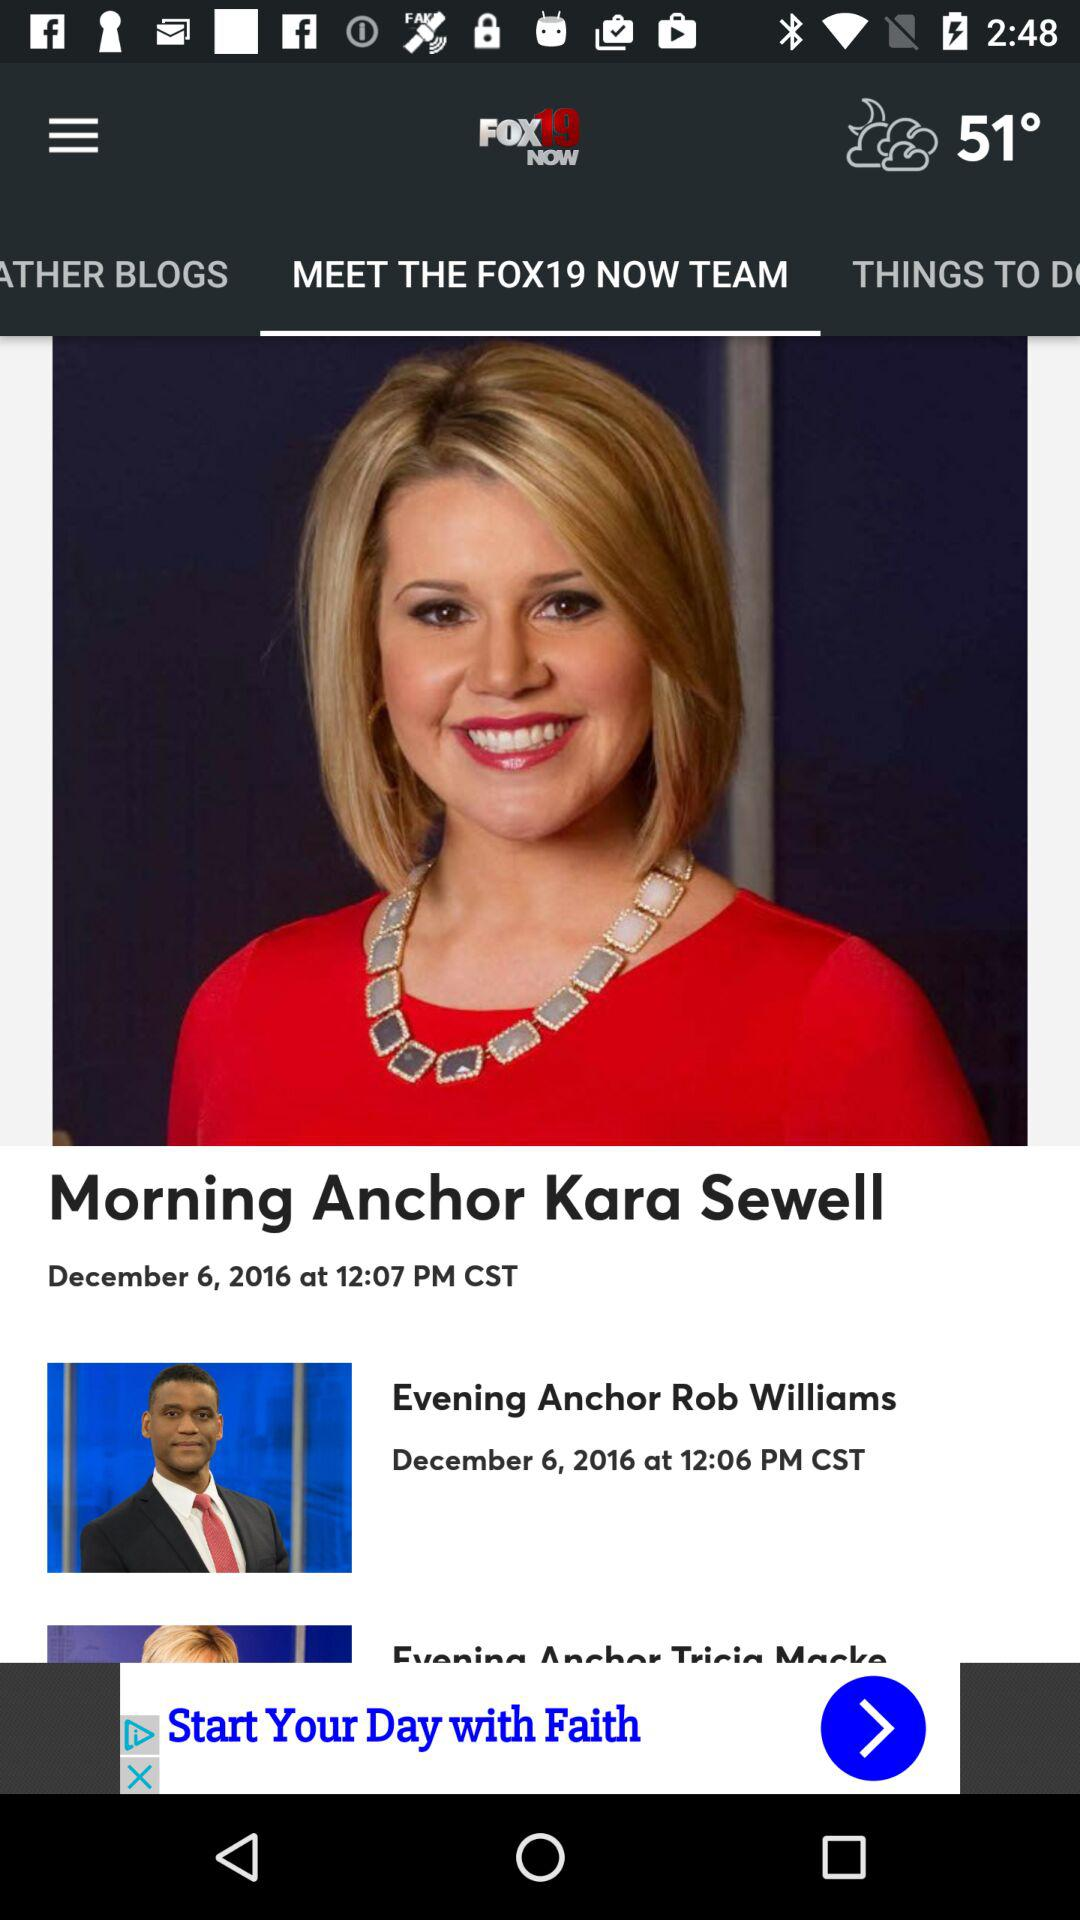On what date was the news "Morning Anchor Kara Sewell" posted? The news was posted on December 6, 2016. 